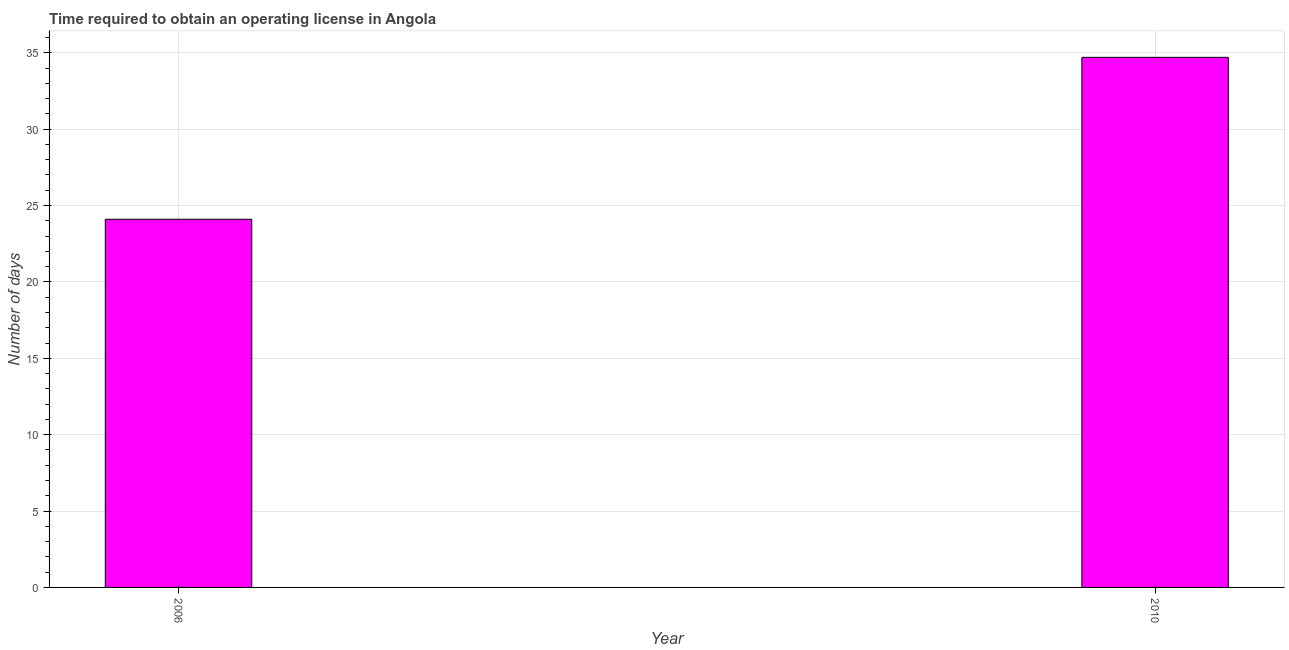Does the graph contain grids?
Offer a very short reply. Yes. What is the title of the graph?
Your answer should be compact. Time required to obtain an operating license in Angola. What is the label or title of the Y-axis?
Make the answer very short. Number of days. What is the number of days to obtain operating license in 2006?
Offer a terse response. 24.1. Across all years, what is the maximum number of days to obtain operating license?
Your response must be concise. 34.7. Across all years, what is the minimum number of days to obtain operating license?
Your answer should be compact. 24.1. In which year was the number of days to obtain operating license minimum?
Keep it short and to the point. 2006. What is the sum of the number of days to obtain operating license?
Ensure brevity in your answer.  58.8. What is the average number of days to obtain operating license per year?
Keep it short and to the point. 29.4. What is the median number of days to obtain operating license?
Offer a very short reply. 29.4. Do a majority of the years between 2006 and 2010 (inclusive) have number of days to obtain operating license greater than 21 days?
Provide a succinct answer. Yes. What is the ratio of the number of days to obtain operating license in 2006 to that in 2010?
Offer a terse response. 0.69. What is the difference between two consecutive major ticks on the Y-axis?
Your answer should be compact. 5. Are the values on the major ticks of Y-axis written in scientific E-notation?
Keep it short and to the point. No. What is the Number of days of 2006?
Make the answer very short. 24.1. What is the Number of days of 2010?
Your answer should be very brief. 34.7. What is the difference between the Number of days in 2006 and 2010?
Offer a terse response. -10.6. What is the ratio of the Number of days in 2006 to that in 2010?
Make the answer very short. 0.69. 